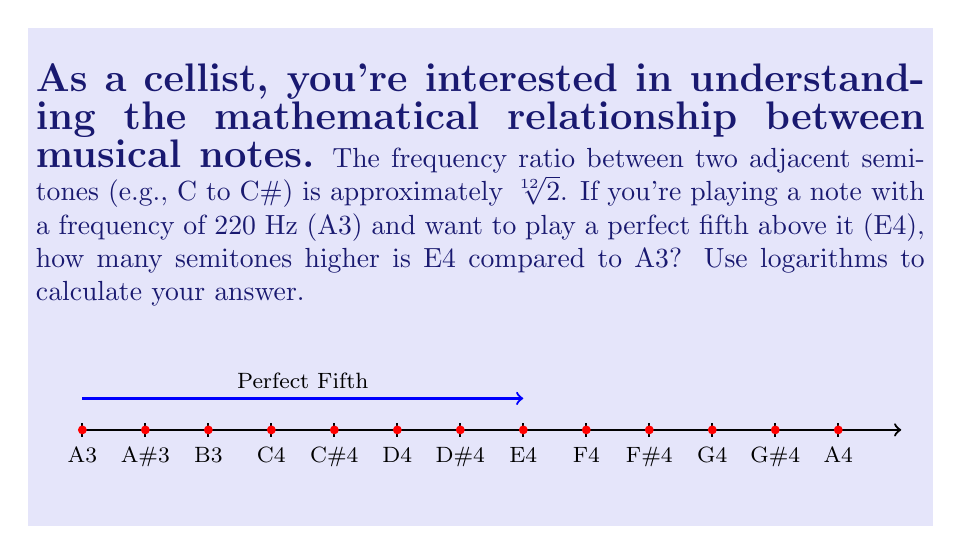Can you answer this question? Let's approach this step-by-step:

1) We know that the frequency ratio between two adjacent semitones is $\sqrt[12]{2}$.

2) Let's call the number of semitones between A3 and E4 as $n$. Then we can write:

   $$\frac{f_{E4}}{f_{A3}} = (\sqrt[12]{2})^n$$

3) We know that a perfect fifth has a frequency ratio of 3:2. So:

   $$\frac{f_{E4}}{f_{A3}} = \frac{3}{2}$$

4) Now we can set up an equation:

   $$(\sqrt[12]{2})^n = \frac{3}{2}$$

5) To solve for $n$, we can take the logarithm of both sides. Let's use base 2 logarithm:

   $$\log_2((\sqrt[12]{2})^n) = \log_2(\frac{3}{2})$$

6) Using the logarithm property $\log_a(x^n) = n\log_a(x)$:

   $$n \cdot \log_2(\sqrt[12]{2}) = \log_2(\frac{3}{2})$$

7) Simplify $\log_2(\sqrt[12]{2})$:

   $$n \cdot \frac{1}{12} = \log_2(\frac{3}{2})$$

8) Solve for $n$:

   $$n = 12 \cdot \log_2(\frac{3}{2}) \approx 7$$

Therefore, E4 is 7 semitones higher than A3.
Answer: 7 semitones 